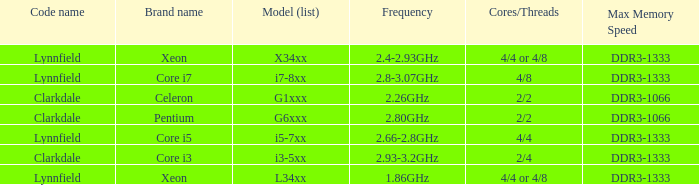What brand is model G6xxx? Pentium. 